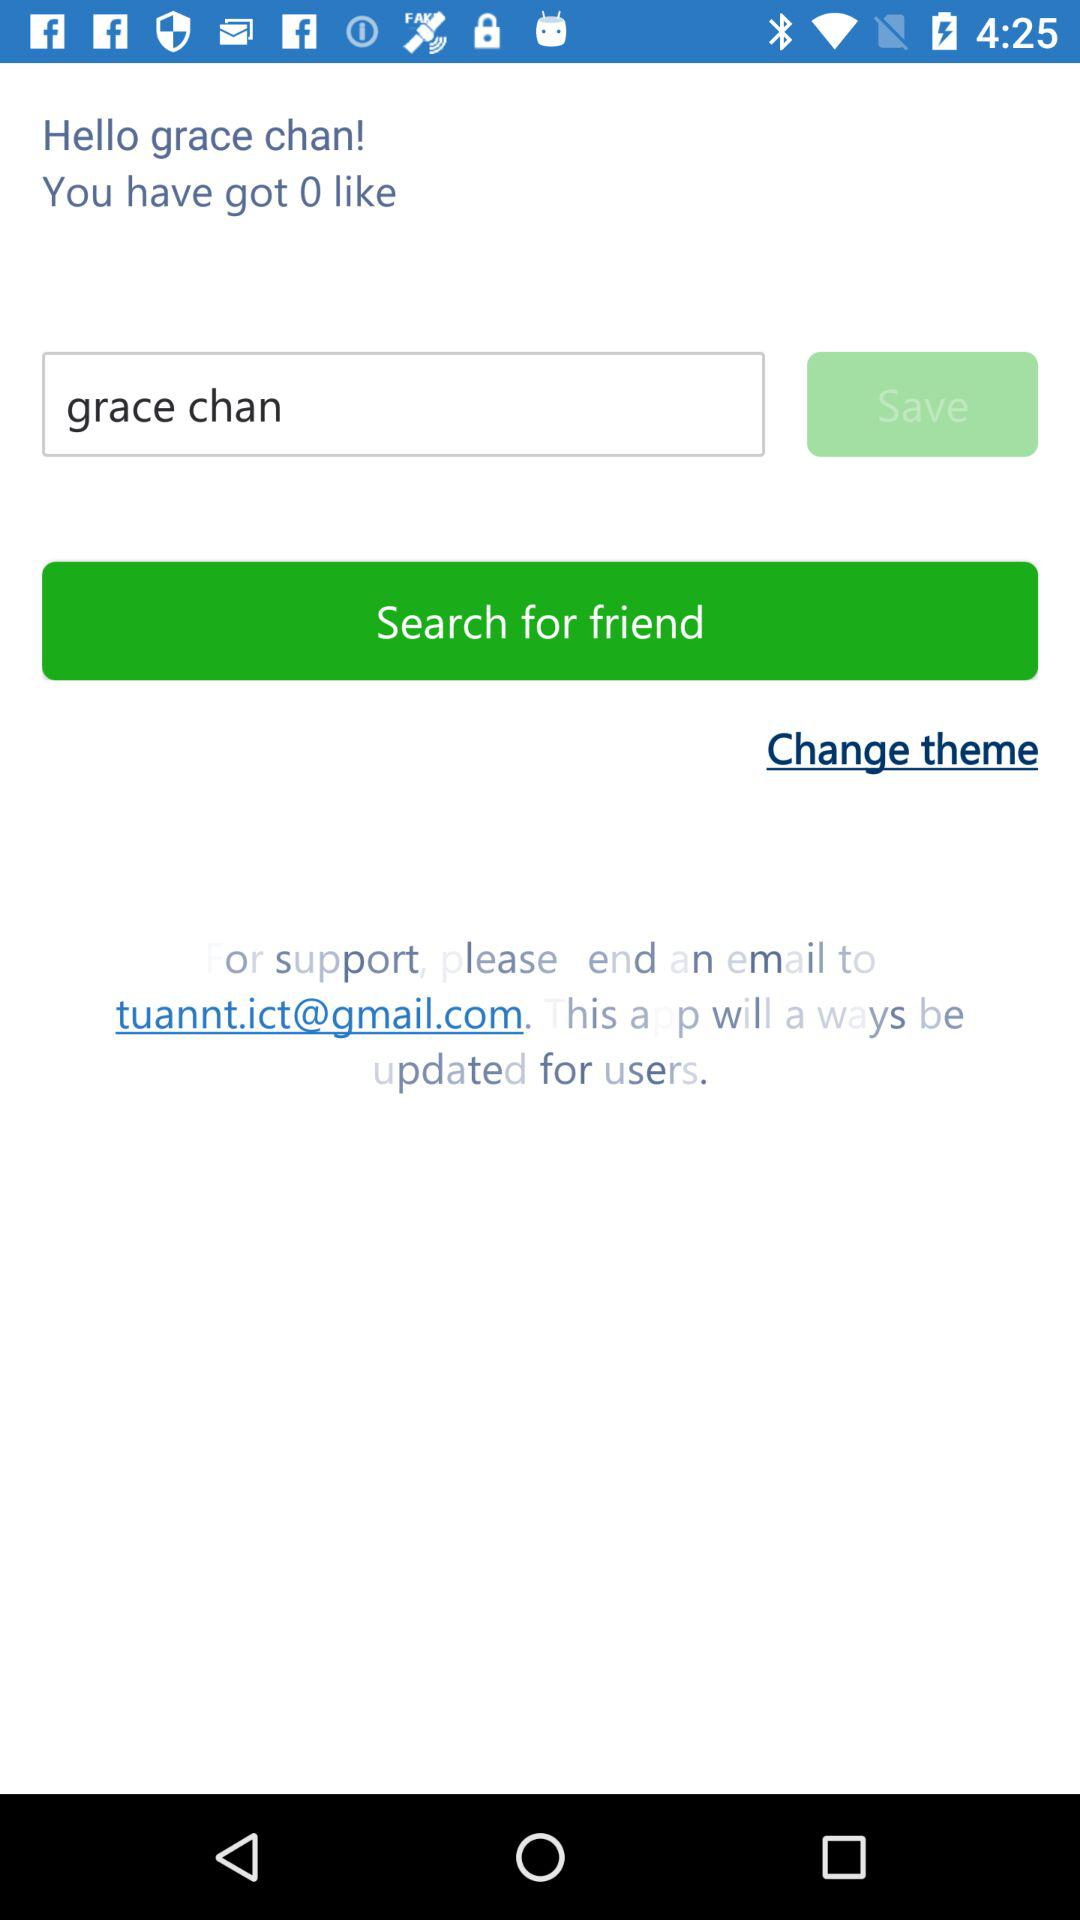How many likes did Grace Chan get? Grace Chan got 0 likes. 